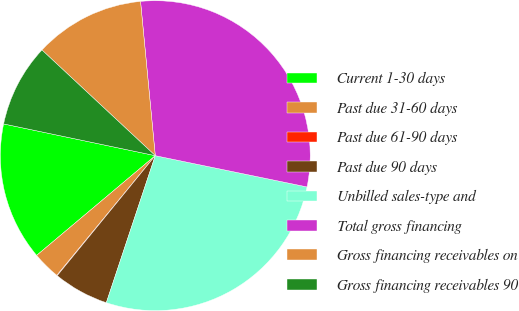Convert chart. <chart><loc_0><loc_0><loc_500><loc_500><pie_chart><fcel>Current 1-30 days<fcel>Past due 31-60 days<fcel>Past due 61-90 days<fcel>Past due 90 days<fcel>Unbilled sales-type and<fcel>Total gross financing<fcel>Gross financing receivables on<fcel>Gross financing receivables 90<nl><fcel>14.41%<fcel>2.92%<fcel>0.05%<fcel>5.79%<fcel>26.88%<fcel>29.75%<fcel>11.54%<fcel>8.66%<nl></chart> 